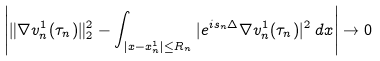<formula> <loc_0><loc_0><loc_500><loc_500>\left | \| \nabla v _ { n } ^ { 1 } ( \tau _ { n } ) \| _ { 2 } ^ { 2 } - \int _ { | x - x _ { n } ^ { 1 } | \leq R _ { n } } | e ^ { i s _ { n } \Delta } \nabla v _ { n } ^ { 1 } ( \tau _ { n } ) | ^ { 2 } \, d x \right | \to 0</formula> 